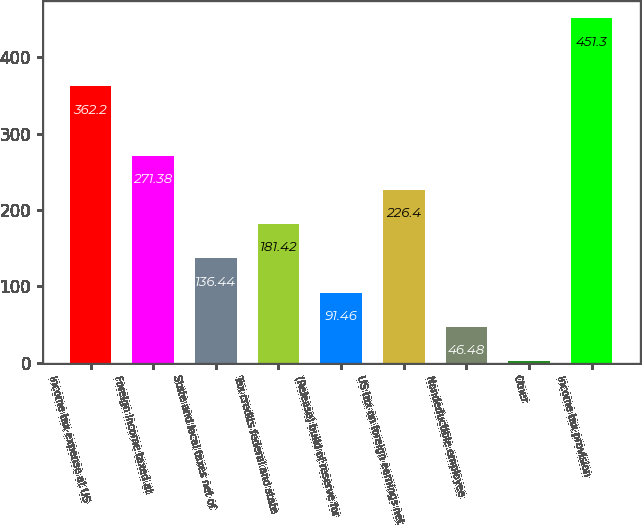<chart> <loc_0><loc_0><loc_500><loc_500><bar_chart><fcel>Income tax expense at US<fcel>Foreign income taxed at<fcel>State and local taxes net of<fcel>Tax credits federal and state<fcel>(Release) build of reserve for<fcel>US tax on foreign earnings net<fcel>Nondeductible employee<fcel>Other<fcel>Income tax provision<nl><fcel>362.2<fcel>271.38<fcel>136.44<fcel>181.42<fcel>91.46<fcel>226.4<fcel>46.48<fcel>1.5<fcel>451.3<nl></chart> 